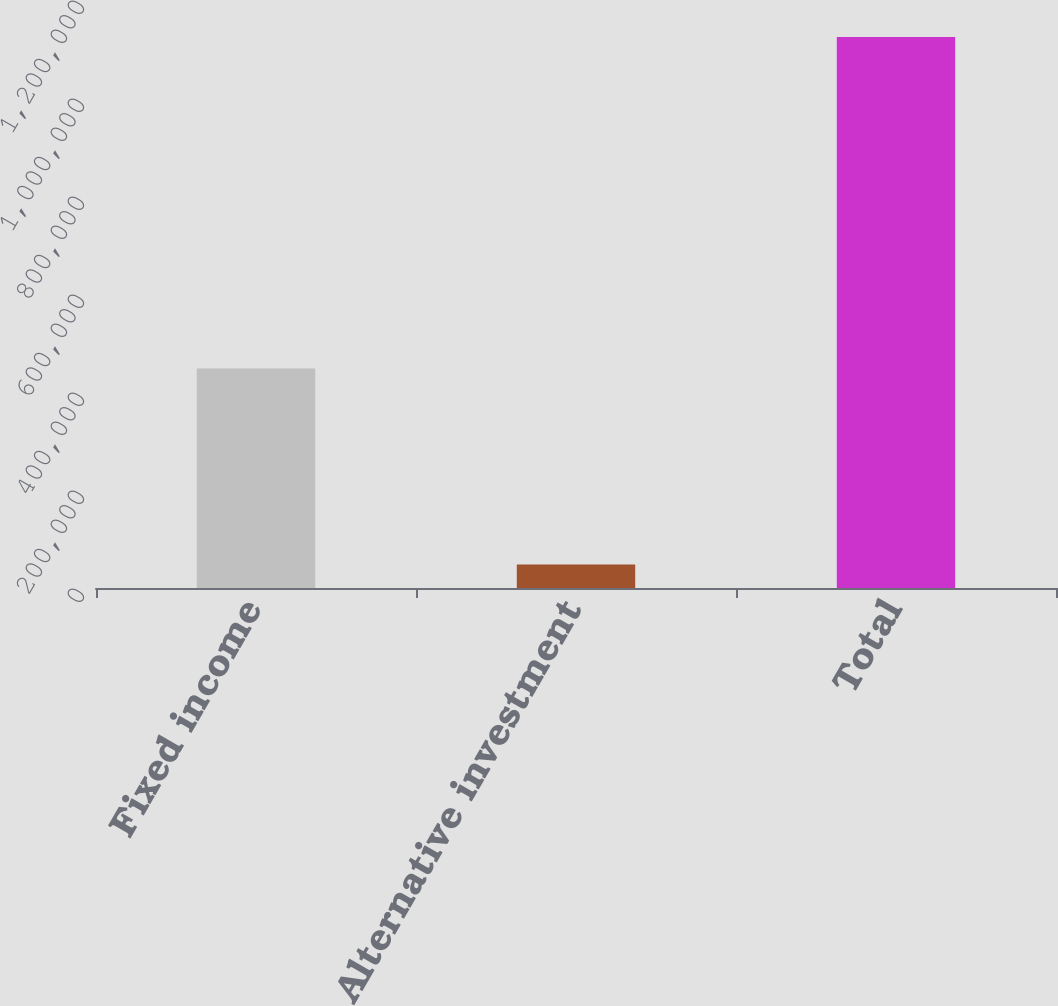Convert chart to OTSL. <chart><loc_0><loc_0><loc_500><loc_500><bar_chart><fcel>Fixed income<fcel>Alternative investment<fcel>Total<nl><fcel>448012<fcel>48139<fcel>1.12463e+06<nl></chart> 